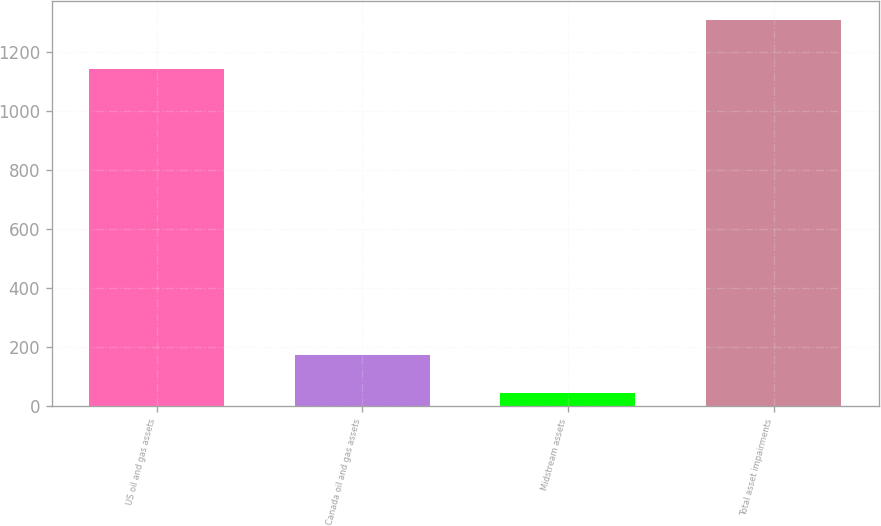Convert chart. <chart><loc_0><loc_0><loc_500><loc_500><bar_chart><fcel>US oil and gas assets<fcel>Canada oil and gas assets<fcel>Midstream assets<fcel>Total asset impairments<nl><fcel>1142<fcel>170.4<fcel>44<fcel>1308<nl></chart> 